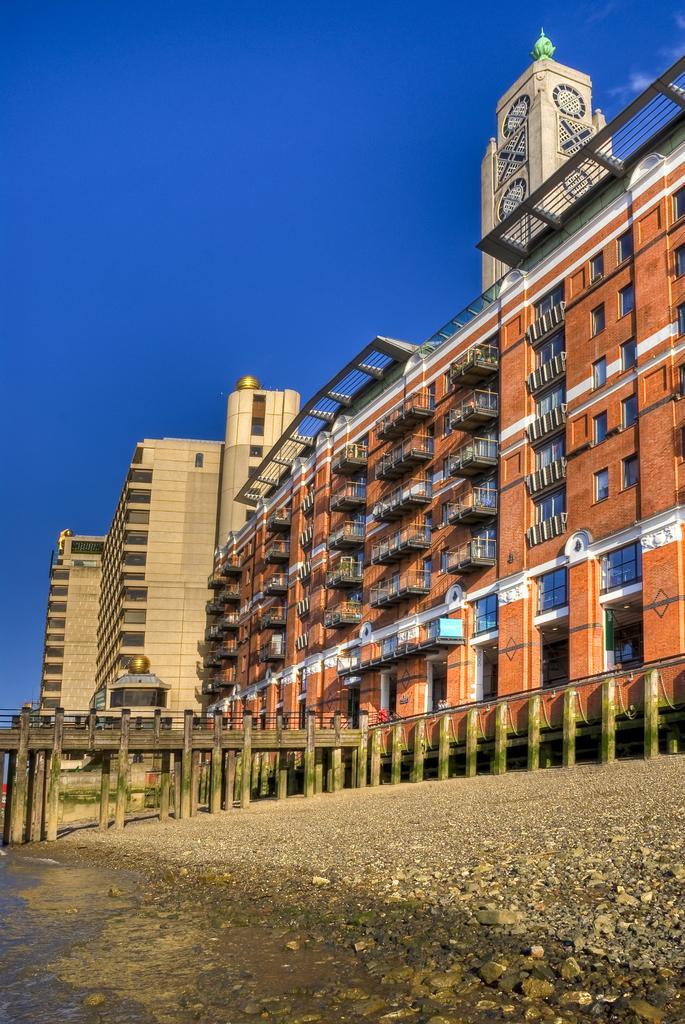Can you describe this image briefly? In this picture I can see a bridge, there are buildings, and in the background there is the sky. 